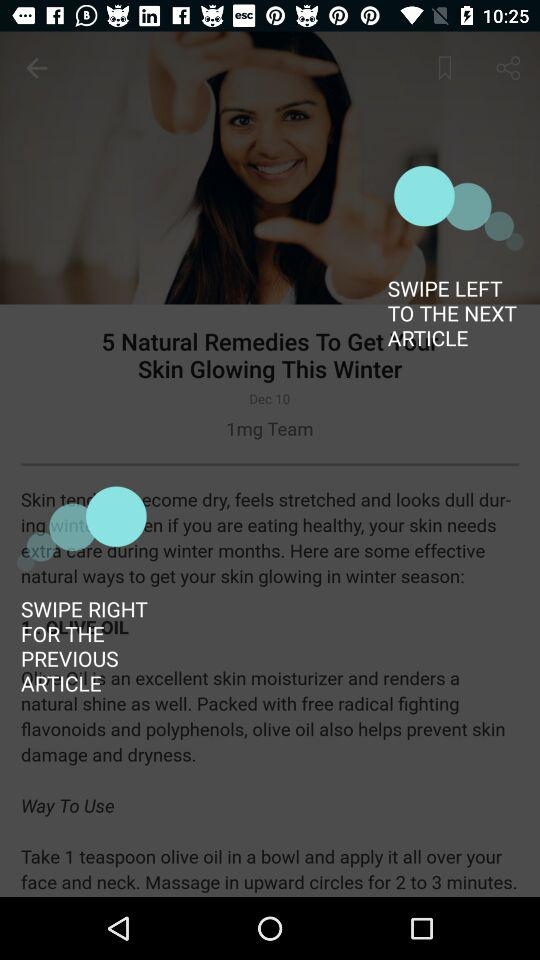What is the status of the option that includes agreement to the “Terms and Conditions”? The status is "on". 